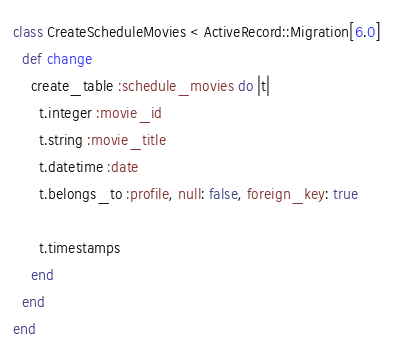<code> <loc_0><loc_0><loc_500><loc_500><_Ruby_>class CreateScheduleMovies < ActiveRecord::Migration[6.0]
  def change
    create_table :schedule_movies do |t|
      t.integer :movie_id
      t.string :movie_title
      t.datetime :date
      t.belongs_to :profile, null: false, foreign_key: true

      t.timestamps
    end
  end
end
</code> 